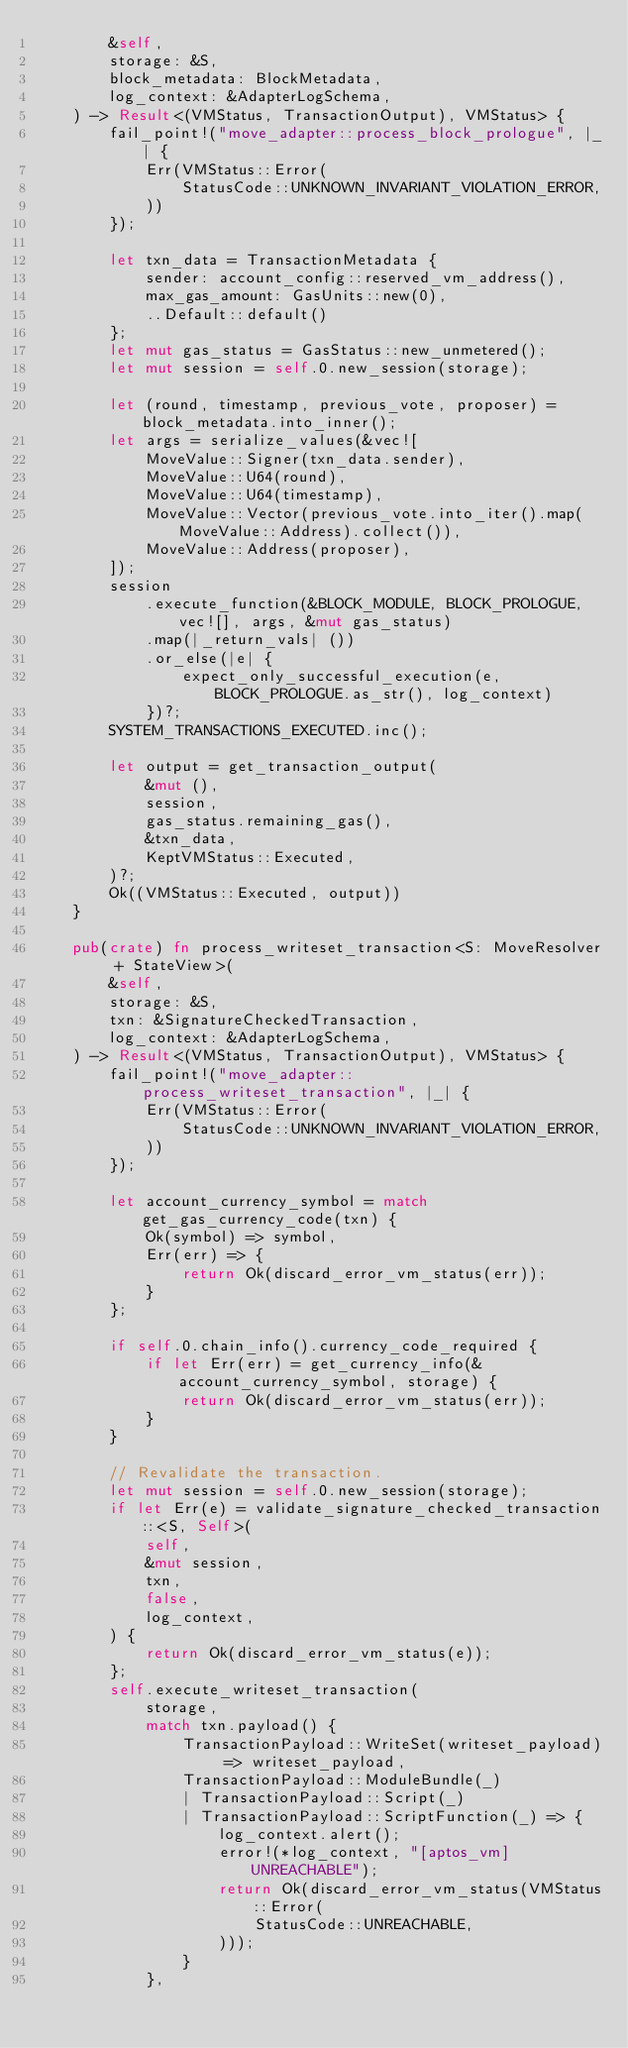<code> <loc_0><loc_0><loc_500><loc_500><_Rust_>        &self,
        storage: &S,
        block_metadata: BlockMetadata,
        log_context: &AdapterLogSchema,
    ) -> Result<(VMStatus, TransactionOutput), VMStatus> {
        fail_point!("move_adapter::process_block_prologue", |_| {
            Err(VMStatus::Error(
                StatusCode::UNKNOWN_INVARIANT_VIOLATION_ERROR,
            ))
        });

        let txn_data = TransactionMetadata {
            sender: account_config::reserved_vm_address(),
            max_gas_amount: GasUnits::new(0),
            ..Default::default()
        };
        let mut gas_status = GasStatus::new_unmetered();
        let mut session = self.0.new_session(storage);

        let (round, timestamp, previous_vote, proposer) = block_metadata.into_inner();
        let args = serialize_values(&vec![
            MoveValue::Signer(txn_data.sender),
            MoveValue::U64(round),
            MoveValue::U64(timestamp),
            MoveValue::Vector(previous_vote.into_iter().map(MoveValue::Address).collect()),
            MoveValue::Address(proposer),
        ]);
        session
            .execute_function(&BLOCK_MODULE, BLOCK_PROLOGUE, vec![], args, &mut gas_status)
            .map(|_return_vals| ())
            .or_else(|e| {
                expect_only_successful_execution(e, BLOCK_PROLOGUE.as_str(), log_context)
            })?;
        SYSTEM_TRANSACTIONS_EXECUTED.inc();

        let output = get_transaction_output(
            &mut (),
            session,
            gas_status.remaining_gas(),
            &txn_data,
            KeptVMStatus::Executed,
        )?;
        Ok((VMStatus::Executed, output))
    }

    pub(crate) fn process_writeset_transaction<S: MoveResolver + StateView>(
        &self,
        storage: &S,
        txn: &SignatureCheckedTransaction,
        log_context: &AdapterLogSchema,
    ) -> Result<(VMStatus, TransactionOutput), VMStatus> {
        fail_point!("move_adapter::process_writeset_transaction", |_| {
            Err(VMStatus::Error(
                StatusCode::UNKNOWN_INVARIANT_VIOLATION_ERROR,
            ))
        });

        let account_currency_symbol = match get_gas_currency_code(txn) {
            Ok(symbol) => symbol,
            Err(err) => {
                return Ok(discard_error_vm_status(err));
            }
        };

        if self.0.chain_info().currency_code_required {
            if let Err(err) = get_currency_info(&account_currency_symbol, storage) {
                return Ok(discard_error_vm_status(err));
            }
        }

        // Revalidate the transaction.
        let mut session = self.0.new_session(storage);
        if let Err(e) = validate_signature_checked_transaction::<S, Self>(
            self,
            &mut session,
            txn,
            false,
            log_context,
        ) {
            return Ok(discard_error_vm_status(e));
        };
        self.execute_writeset_transaction(
            storage,
            match txn.payload() {
                TransactionPayload::WriteSet(writeset_payload) => writeset_payload,
                TransactionPayload::ModuleBundle(_)
                | TransactionPayload::Script(_)
                | TransactionPayload::ScriptFunction(_) => {
                    log_context.alert();
                    error!(*log_context, "[aptos_vm] UNREACHABLE");
                    return Ok(discard_error_vm_status(VMStatus::Error(
                        StatusCode::UNREACHABLE,
                    )));
                }
            },</code> 